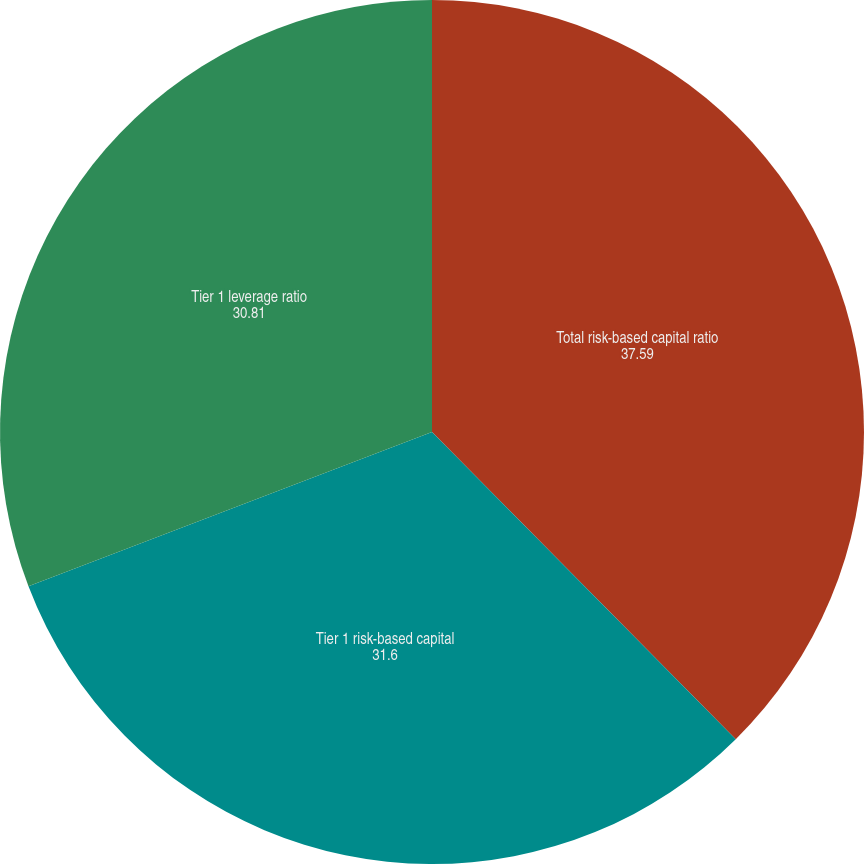Convert chart to OTSL. <chart><loc_0><loc_0><loc_500><loc_500><pie_chart><fcel>Total risk-based capital ratio<fcel>Tier 1 risk-based capital<fcel>Tier 1 leverage ratio<nl><fcel>37.59%<fcel>31.6%<fcel>30.81%<nl></chart> 